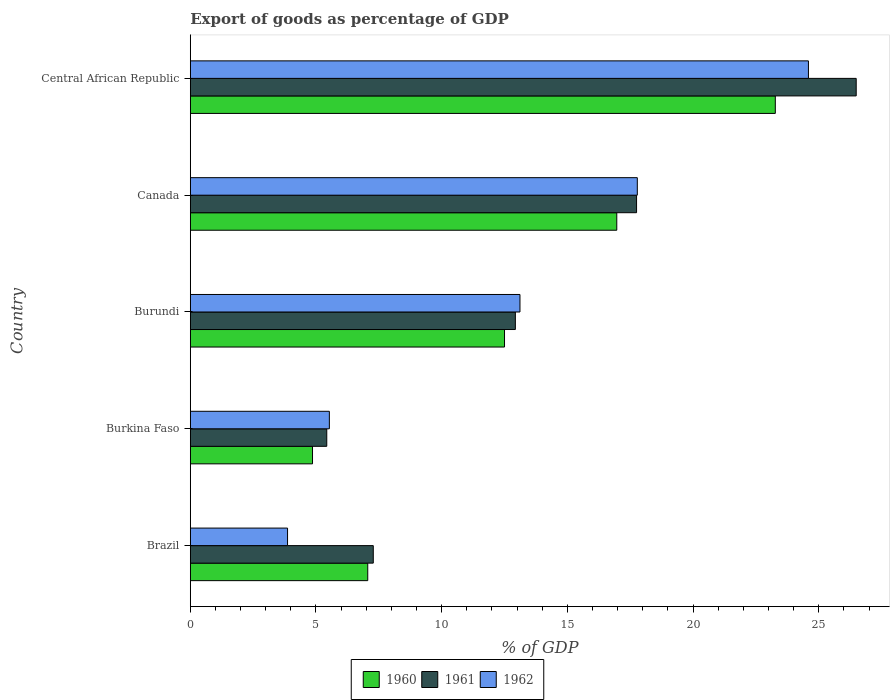How many groups of bars are there?
Your response must be concise. 5. Are the number of bars on each tick of the Y-axis equal?
Ensure brevity in your answer.  Yes. What is the export of goods as percentage of GDP in 1960 in Burkina Faso?
Provide a short and direct response. 4.86. Across all countries, what is the maximum export of goods as percentage of GDP in 1962?
Give a very brief answer. 24.59. Across all countries, what is the minimum export of goods as percentage of GDP in 1960?
Give a very brief answer. 4.86. In which country was the export of goods as percentage of GDP in 1960 maximum?
Provide a short and direct response. Central African Republic. What is the total export of goods as percentage of GDP in 1962 in the graph?
Give a very brief answer. 64.89. What is the difference between the export of goods as percentage of GDP in 1960 in Brazil and that in Burundi?
Make the answer very short. -5.44. What is the difference between the export of goods as percentage of GDP in 1962 in Burundi and the export of goods as percentage of GDP in 1961 in Brazil?
Keep it short and to the point. 5.84. What is the average export of goods as percentage of GDP in 1962 per country?
Offer a very short reply. 12.98. What is the difference between the export of goods as percentage of GDP in 1961 and export of goods as percentage of GDP in 1962 in Burundi?
Keep it short and to the point. -0.18. In how many countries, is the export of goods as percentage of GDP in 1962 greater than 14 %?
Offer a terse response. 2. What is the ratio of the export of goods as percentage of GDP in 1960 in Burundi to that in Central African Republic?
Make the answer very short. 0.54. Is the difference between the export of goods as percentage of GDP in 1961 in Canada and Central African Republic greater than the difference between the export of goods as percentage of GDP in 1962 in Canada and Central African Republic?
Your answer should be very brief. No. What is the difference between the highest and the second highest export of goods as percentage of GDP in 1962?
Ensure brevity in your answer.  6.81. What is the difference between the highest and the lowest export of goods as percentage of GDP in 1962?
Ensure brevity in your answer.  20.72. In how many countries, is the export of goods as percentage of GDP in 1962 greater than the average export of goods as percentage of GDP in 1962 taken over all countries?
Offer a terse response. 3. Is the sum of the export of goods as percentage of GDP in 1960 in Burkina Faso and Canada greater than the maximum export of goods as percentage of GDP in 1961 across all countries?
Provide a succinct answer. No. What does the 2nd bar from the top in Burundi represents?
Give a very brief answer. 1961. Is it the case that in every country, the sum of the export of goods as percentage of GDP in 1960 and export of goods as percentage of GDP in 1962 is greater than the export of goods as percentage of GDP in 1961?
Your response must be concise. Yes. How many bars are there?
Give a very brief answer. 15. Are all the bars in the graph horizontal?
Offer a very short reply. Yes. How many countries are there in the graph?
Keep it short and to the point. 5. What is the difference between two consecutive major ticks on the X-axis?
Your answer should be compact. 5. Does the graph contain grids?
Offer a very short reply. No. How many legend labels are there?
Your answer should be very brief. 3. How are the legend labels stacked?
Provide a succinct answer. Horizontal. What is the title of the graph?
Offer a very short reply. Export of goods as percentage of GDP. What is the label or title of the X-axis?
Keep it short and to the point. % of GDP. What is the label or title of the Y-axis?
Offer a very short reply. Country. What is the % of GDP in 1960 in Brazil?
Your response must be concise. 7.06. What is the % of GDP in 1961 in Brazil?
Offer a very short reply. 7.28. What is the % of GDP in 1962 in Brazil?
Your answer should be very brief. 3.87. What is the % of GDP in 1960 in Burkina Faso?
Provide a short and direct response. 4.86. What is the % of GDP of 1961 in Burkina Faso?
Give a very brief answer. 5.43. What is the % of GDP of 1962 in Burkina Faso?
Make the answer very short. 5.53. What is the % of GDP of 1960 in Burundi?
Your answer should be compact. 12.5. What is the % of GDP of 1961 in Burundi?
Your answer should be compact. 12.93. What is the % of GDP in 1962 in Burundi?
Offer a terse response. 13.11. What is the % of GDP of 1960 in Canada?
Your answer should be compact. 16.97. What is the % of GDP of 1961 in Canada?
Ensure brevity in your answer.  17.75. What is the % of GDP of 1962 in Canada?
Offer a terse response. 17.78. What is the % of GDP in 1960 in Central African Republic?
Your answer should be very brief. 23.27. What is the % of GDP of 1961 in Central African Republic?
Offer a terse response. 26.49. What is the % of GDP in 1962 in Central African Republic?
Ensure brevity in your answer.  24.59. Across all countries, what is the maximum % of GDP in 1960?
Keep it short and to the point. 23.27. Across all countries, what is the maximum % of GDP in 1961?
Make the answer very short. 26.49. Across all countries, what is the maximum % of GDP of 1962?
Give a very brief answer. 24.59. Across all countries, what is the minimum % of GDP of 1960?
Give a very brief answer. 4.86. Across all countries, what is the minimum % of GDP in 1961?
Your answer should be compact. 5.43. Across all countries, what is the minimum % of GDP in 1962?
Offer a very short reply. 3.87. What is the total % of GDP in 1960 in the graph?
Your answer should be compact. 64.66. What is the total % of GDP in 1961 in the graph?
Offer a terse response. 69.88. What is the total % of GDP of 1962 in the graph?
Keep it short and to the point. 64.89. What is the difference between the % of GDP of 1960 in Brazil and that in Burkina Faso?
Your response must be concise. 2.2. What is the difference between the % of GDP in 1961 in Brazil and that in Burkina Faso?
Your answer should be very brief. 1.85. What is the difference between the % of GDP of 1962 in Brazil and that in Burkina Faso?
Provide a short and direct response. -1.66. What is the difference between the % of GDP of 1960 in Brazil and that in Burundi?
Ensure brevity in your answer.  -5.44. What is the difference between the % of GDP of 1961 in Brazil and that in Burundi?
Your answer should be very brief. -5.65. What is the difference between the % of GDP in 1962 in Brazil and that in Burundi?
Offer a very short reply. -9.25. What is the difference between the % of GDP in 1960 in Brazil and that in Canada?
Provide a short and direct response. -9.91. What is the difference between the % of GDP in 1961 in Brazil and that in Canada?
Provide a short and direct response. -10.47. What is the difference between the % of GDP of 1962 in Brazil and that in Canada?
Keep it short and to the point. -13.91. What is the difference between the % of GDP in 1960 in Brazil and that in Central African Republic?
Provide a short and direct response. -16.21. What is the difference between the % of GDP in 1961 in Brazil and that in Central African Republic?
Your answer should be very brief. -19.21. What is the difference between the % of GDP of 1962 in Brazil and that in Central African Republic?
Ensure brevity in your answer.  -20.72. What is the difference between the % of GDP in 1960 in Burkina Faso and that in Burundi?
Your answer should be very brief. -7.64. What is the difference between the % of GDP in 1961 in Burkina Faso and that in Burundi?
Your answer should be compact. -7.5. What is the difference between the % of GDP in 1962 in Burkina Faso and that in Burundi?
Give a very brief answer. -7.58. What is the difference between the % of GDP of 1960 in Burkina Faso and that in Canada?
Offer a terse response. -12.1. What is the difference between the % of GDP of 1961 in Burkina Faso and that in Canada?
Your answer should be very brief. -12.32. What is the difference between the % of GDP in 1962 in Burkina Faso and that in Canada?
Make the answer very short. -12.25. What is the difference between the % of GDP in 1960 in Burkina Faso and that in Central African Republic?
Your answer should be very brief. -18.41. What is the difference between the % of GDP of 1961 in Burkina Faso and that in Central African Republic?
Provide a short and direct response. -21.06. What is the difference between the % of GDP in 1962 in Burkina Faso and that in Central African Republic?
Keep it short and to the point. -19.06. What is the difference between the % of GDP in 1960 in Burundi and that in Canada?
Keep it short and to the point. -4.47. What is the difference between the % of GDP in 1961 in Burundi and that in Canada?
Make the answer very short. -4.82. What is the difference between the % of GDP in 1962 in Burundi and that in Canada?
Your response must be concise. -4.67. What is the difference between the % of GDP in 1960 in Burundi and that in Central African Republic?
Provide a succinct answer. -10.77. What is the difference between the % of GDP of 1961 in Burundi and that in Central African Republic?
Provide a short and direct response. -13.56. What is the difference between the % of GDP in 1962 in Burundi and that in Central African Republic?
Your answer should be very brief. -11.48. What is the difference between the % of GDP in 1960 in Canada and that in Central African Republic?
Your answer should be very brief. -6.31. What is the difference between the % of GDP of 1961 in Canada and that in Central African Republic?
Your answer should be very brief. -8.74. What is the difference between the % of GDP of 1962 in Canada and that in Central African Republic?
Your answer should be very brief. -6.81. What is the difference between the % of GDP in 1960 in Brazil and the % of GDP in 1961 in Burkina Faso?
Your answer should be compact. 1.63. What is the difference between the % of GDP of 1960 in Brazil and the % of GDP of 1962 in Burkina Faso?
Your response must be concise. 1.53. What is the difference between the % of GDP in 1961 in Brazil and the % of GDP in 1962 in Burkina Faso?
Your answer should be compact. 1.75. What is the difference between the % of GDP in 1960 in Brazil and the % of GDP in 1961 in Burundi?
Keep it short and to the point. -5.87. What is the difference between the % of GDP in 1960 in Brazil and the % of GDP in 1962 in Burundi?
Your answer should be very brief. -6.06. What is the difference between the % of GDP of 1961 in Brazil and the % of GDP of 1962 in Burundi?
Provide a short and direct response. -5.84. What is the difference between the % of GDP of 1960 in Brazil and the % of GDP of 1961 in Canada?
Your answer should be very brief. -10.69. What is the difference between the % of GDP of 1960 in Brazil and the % of GDP of 1962 in Canada?
Offer a terse response. -10.72. What is the difference between the % of GDP in 1961 in Brazil and the % of GDP in 1962 in Canada?
Your response must be concise. -10.5. What is the difference between the % of GDP in 1960 in Brazil and the % of GDP in 1961 in Central African Republic?
Your answer should be very brief. -19.43. What is the difference between the % of GDP in 1960 in Brazil and the % of GDP in 1962 in Central African Republic?
Keep it short and to the point. -17.53. What is the difference between the % of GDP in 1961 in Brazil and the % of GDP in 1962 in Central African Republic?
Your response must be concise. -17.31. What is the difference between the % of GDP in 1960 in Burkina Faso and the % of GDP in 1961 in Burundi?
Your answer should be very brief. -8.07. What is the difference between the % of GDP in 1960 in Burkina Faso and the % of GDP in 1962 in Burundi?
Your answer should be very brief. -8.25. What is the difference between the % of GDP in 1961 in Burkina Faso and the % of GDP in 1962 in Burundi?
Provide a short and direct response. -7.69. What is the difference between the % of GDP of 1960 in Burkina Faso and the % of GDP of 1961 in Canada?
Provide a succinct answer. -12.89. What is the difference between the % of GDP of 1960 in Burkina Faso and the % of GDP of 1962 in Canada?
Provide a succinct answer. -12.92. What is the difference between the % of GDP of 1961 in Burkina Faso and the % of GDP of 1962 in Canada?
Your answer should be compact. -12.35. What is the difference between the % of GDP of 1960 in Burkina Faso and the % of GDP of 1961 in Central African Republic?
Keep it short and to the point. -21.63. What is the difference between the % of GDP of 1960 in Burkina Faso and the % of GDP of 1962 in Central African Republic?
Provide a succinct answer. -19.73. What is the difference between the % of GDP of 1961 in Burkina Faso and the % of GDP of 1962 in Central African Republic?
Provide a succinct answer. -19.16. What is the difference between the % of GDP in 1960 in Burundi and the % of GDP in 1961 in Canada?
Provide a succinct answer. -5.25. What is the difference between the % of GDP of 1960 in Burundi and the % of GDP of 1962 in Canada?
Make the answer very short. -5.28. What is the difference between the % of GDP in 1961 in Burundi and the % of GDP in 1962 in Canada?
Provide a succinct answer. -4.85. What is the difference between the % of GDP in 1960 in Burundi and the % of GDP in 1961 in Central African Republic?
Keep it short and to the point. -13.99. What is the difference between the % of GDP of 1960 in Burundi and the % of GDP of 1962 in Central African Republic?
Provide a succinct answer. -12.09. What is the difference between the % of GDP of 1961 in Burundi and the % of GDP of 1962 in Central African Republic?
Your answer should be compact. -11.66. What is the difference between the % of GDP in 1960 in Canada and the % of GDP in 1961 in Central African Republic?
Your answer should be compact. -9.52. What is the difference between the % of GDP of 1960 in Canada and the % of GDP of 1962 in Central African Republic?
Offer a terse response. -7.62. What is the difference between the % of GDP of 1961 in Canada and the % of GDP of 1962 in Central African Republic?
Your answer should be very brief. -6.84. What is the average % of GDP of 1960 per country?
Your answer should be compact. 12.93. What is the average % of GDP of 1961 per country?
Make the answer very short. 13.98. What is the average % of GDP in 1962 per country?
Provide a short and direct response. 12.98. What is the difference between the % of GDP of 1960 and % of GDP of 1961 in Brazil?
Your answer should be compact. -0.22. What is the difference between the % of GDP in 1960 and % of GDP in 1962 in Brazil?
Offer a very short reply. 3.19. What is the difference between the % of GDP in 1961 and % of GDP in 1962 in Brazil?
Ensure brevity in your answer.  3.41. What is the difference between the % of GDP of 1960 and % of GDP of 1961 in Burkina Faso?
Your answer should be very brief. -0.57. What is the difference between the % of GDP in 1960 and % of GDP in 1962 in Burkina Faso?
Offer a very short reply. -0.67. What is the difference between the % of GDP of 1961 and % of GDP of 1962 in Burkina Faso?
Your answer should be compact. -0.1. What is the difference between the % of GDP of 1960 and % of GDP of 1961 in Burundi?
Your answer should be very brief. -0.43. What is the difference between the % of GDP of 1960 and % of GDP of 1962 in Burundi?
Offer a very short reply. -0.61. What is the difference between the % of GDP in 1961 and % of GDP in 1962 in Burundi?
Give a very brief answer. -0.18. What is the difference between the % of GDP in 1960 and % of GDP in 1961 in Canada?
Your answer should be compact. -0.79. What is the difference between the % of GDP of 1960 and % of GDP of 1962 in Canada?
Provide a succinct answer. -0.82. What is the difference between the % of GDP of 1961 and % of GDP of 1962 in Canada?
Provide a succinct answer. -0.03. What is the difference between the % of GDP of 1960 and % of GDP of 1961 in Central African Republic?
Give a very brief answer. -3.22. What is the difference between the % of GDP of 1960 and % of GDP of 1962 in Central African Republic?
Offer a terse response. -1.32. What is the difference between the % of GDP of 1961 and % of GDP of 1962 in Central African Republic?
Your response must be concise. 1.9. What is the ratio of the % of GDP in 1960 in Brazil to that in Burkina Faso?
Offer a terse response. 1.45. What is the ratio of the % of GDP in 1961 in Brazil to that in Burkina Faso?
Offer a terse response. 1.34. What is the ratio of the % of GDP of 1962 in Brazil to that in Burkina Faso?
Offer a very short reply. 0.7. What is the ratio of the % of GDP in 1960 in Brazil to that in Burundi?
Ensure brevity in your answer.  0.56. What is the ratio of the % of GDP of 1961 in Brazil to that in Burundi?
Your answer should be compact. 0.56. What is the ratio of the % of GDP of 1962 in Brazil to that in Burundi?
Provide a short and direct response. 0.29. What is the ratio of the % of GDP in 1960 in Brazil to that in Canada?
Provide a short and direct response. 0.42. What is the ratio of the % of GDP in 1961 in Brazil to that in Canada?
Offer a very short reply. 0.41. What is the ratio of the % of GDP in 1962 in Brazil to that in Canada?
Make the answer very short. 0.22. What is the ratio of the % of GDP of 1960 in Brazil to that in Central African Republic?
Your answer should be compact. 0.3. What is the ratio of the % of GDP in 1961 in Brazil to that in Central African Republic?
Keep it short and to the point. 0.27. What is the ratio of the % of GDP in 1962 in Brazil to that in Central African Republic?
Your answer should be compact. 0.16. What is the ratio of the % of GDP in 1960 in Burkina Faso to that in Burundi?
Your response must be concise. 0.39. What is the ratio of the % of GDP of 1961 in Burkina Faso to that in Burundi?
Provide a short and direct response. 0.42. What is the ratio of the % of GDP in 1962 in Burkina Faso to that in Burundi?
Your response must be concise. 0.42. What is the ratio of the % of GDP of 1960 in Burkina Faso to that in Canada?
Make the answer very short. 0.29. What is the ratio of the % of GDP of 1961 in Burkina Faso to that in Canada?
Give a very brief answer. 0.31. What is the ratio of the % of GDP of 1962 in Burkina Faso to that in Canada?
Give a very brief answer. 0.31. What is the ratio of the % of GDP in 1960 in Burkina Faso to that in Central African Republic?
Offer a very short reply. 0.21. What is the ratio of the % of GDP in 1961 in Burkina Faso to that in Central African Republic?
Offer a very short reply. 0.2. What is the ratio of the % of GDP in 1962 in Burkina Faso to that in Central African Republic?
Provide a succinct answer. 0.23. What is the ratio of the % of GDP of 1960 in Burundi to that in Canada?
Keep it short and to the point. 0.74. What is the ratio of the % of GDP of 1961 in Burundi to that in Canada?
Ensure brevity in your answer.  0.73. What is the ratio of the % of GDP of 1962 in Burundi to that in Canada?
Make the answer very short. 0.74. What is the ratio of the % of GDP of 1960 in Burundi to that in Central African Republic?
Offer a very short reply. 0.54. What is the ratio of the % of GDP in 1961 in Burundi to that in Central African Republic?
Your answer should be very brief. 0.49. What is the ratio of the % of GDP in 1962 in Burundi to that in Central African Republic?
Your answer should be very brief. 0.53. What is the ratio of the % of GDP in 1960 in Canada to that in Central African Republic?
Give a very brief answer. 0.73. What is the ratio of the % of GDP in 1961 in Canada to that in Central African Republic?
Ensure brevity in your answer.  0.67. What is the ratio of the % of GDP in 1962 in Canada to that in Central African Republic?
Keep it short and to the point. 0.72. What is the difference between the highest and the second highest % of GDP in 1960?
Your response must be concise. 6.31. What is the difference between the highest and the second highest % of GDP of 1961?
Keep it short and to the point. 8.74. What is the difference between the highest and the second highest % of GDP of 1962?
Your response must be concise. 6.81. What is the difference between the highest and the lowest % of GDP of 1960?
Your answer should be compact. 18.41. What is the difference between the highest and the lowest % of GDP in 1961?
Give a very brief answer. 21.06. What is the difference between the highest and the lowest % of GDP of 1962?
Your answer should be very brief. 20.72. 